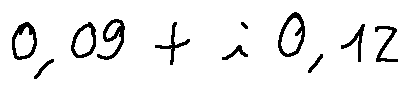<formula> <loc_0><loc_0><loc_500><loc_500>0 , 0 9 + i 0 , 1 2</formula> 